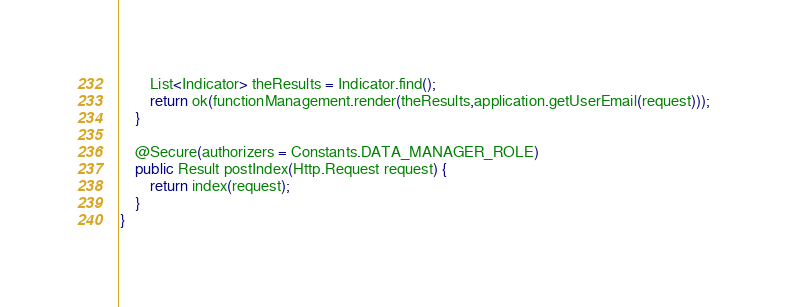<code> <loc_0><loc_0><loc_500><loc_500><_Java_>    	List<Indicator> theResults = Indicator.find();
        return ok(functionManagement.render(theResults,application.getUserEmail(request)));
    }

    @Secure(authorizers = Constants.DATA_MANAGER_ROLE)
    public Result postIndex(Http.Request request) {
        return index(request);
    }
}
</code> 